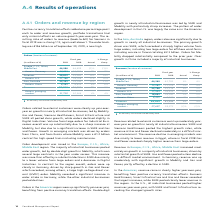According to Siemens Ag's financial document, How has the Positive currency translation affected the revenue? Positive currency translation effects added one percentage point each to order and revenue growth; portfolio transactions had only minimal effects on volume growth year-over-year.. The document states: "Positive currency translation effects added one percentage point each to order and revenue growth; portfolio transactions had only minimal effects on ..." Also, What drove the growth in the emerging markets? Growth in emerging markets was driven by orders from China, and from Russia where Mobility won a € 1.2 billion contract for high-speed trains including maintenance.. The document states: "a significant increase in SGRE and Gas and Power. Growth in emerging markets was driven by orders from China, and from Russia where Mobility won a € 1..." Also, What drove the increase in the orders in the Americas region? Orders in the Americas region were up significantly year-over-year, benefiting from positive currency translation effects. Double-digit growth in nearly all industrial businesses was led by SGRE and Mobility with particularly sharp increases. The pattern of order development in the U. S. was largely the same as in the Americas region.. The document states: "Orders in the Americas region were up significantly year-over-year, benefiting from positive currency translation effects. Double-digit growth in near..." Also, can you calculate: What was the average orders in the Americas region in 2019 and 2018? To answer this question, I need to perform calculations using the financial data. The calculation is: (29,812 + 25,060) / 2, which equals 27436 (in millions). This is based on the information: "Americas 29,812 25,060 19 % 14 % Americas 29,812 25,060 19 % 14 %..." The key data points involved are: 25,060, 29,812. Also, can you calculate: What is the increase / (decrease) in the orders for Asia and Australia from 2018 to 2019? Based on the calculation: 22,101 - 19,742, the result is 2359 (in millions). This is based on the information: "Asia, Australia 22,101 19,742 12 % 11 % Asia, Australia 22,101 19,742 12 % 11 %..." The key data points involved are: 19,742, 22,101. Also, can you calculate: What is the percentage increase in the orders for Siemens from 2019 to 2018? To answer this question, I need to perform calculations using the financial data. The calculation is: 97,999 / 91,296 - 1, which equals 7.34 (percentage). This is based on the information: "Siemens 97,999 91,296 7 % 6 % Siemens 97,999 91,296 7 % 6 %..." The key data points involved are: 91,296, 97,999. 